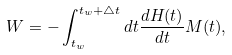<formula> <loc_0><loc_0><loc_500><loc_500>W = - \int _ { t _ { w } } ^ { t _ { w } + \triangle t } d t \frac { d H ( t ) } { d t } M ( t ) ,</formula> 